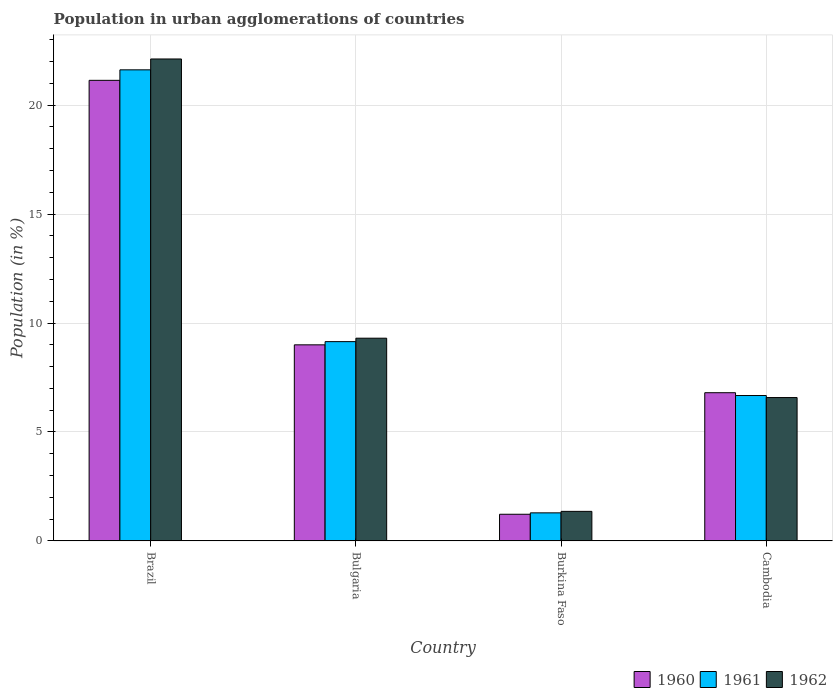How many groups of bars are there?
Make the answer very short. 4. Are the number of bars per tick equal to the number of legend labels?
Your answer should be compact. Yes. How many bars are there on the 4th tick from the right?
Make the answer very short. 3. What is the label of the 4th group of bars from the left?
Your response must be concise. Cambodia. What is the percentage of population in urban agglomerations in 1962 in Cambodia?
Offer a very short reply. 6.58. Across all countries, what is the maximum percentage of population in urban agglomerations in 1961?
Give a very brief answer. 21.62. Across all countries, what is the minimum percentage of population in urban agglomerations in 1960?
Provide a short and direct response. 1.22. In which country was the percentage of population in urban agglomerations in 1961 maximum?
Your answer should be compact. Brazil. In which country was the percentage of population in urban agglomerations in 1961 minimum?
Make the answer very short. Burkina Faso. What is the total percentage of population in urban agglomerations in 1961 in the graph?
Provide a succinct answer. 38.73. What is the difference between the percentage of population in urban agglomerations in 1960 in Brazil and that in Burkina Faso?
Your answer should be compact. 19.91. What is the difference between the percentage of population in urban agglomerations in 1960 in Brazil and the percentage of population in urban agglomerations in 1961 in Bulgaria?
Offer a very short reply. 11.99. What is the average percentage of population in urban agglomerations in 1961 per country?
Ensure brevity in your answer.  9.68. What is the difference between the percentage of population in urban agglomerations of/in 1962 and percentage of population in urban agglomerations of/in 1961 in Cambodia?
Your answer should be compact. -0.09. In how many countries, is the percentage of population in urban agglomerations in 1960 greater than 18 %?
Provide a short and direct response. 1. What is the ratio of the percentage of population in urban agglomerations in 1961 in Brazil to that in Burkina Faso?
Your answer should be compact. 16.77. Is the percentage of population in urban agglomerations in 1961 in Bulgaria less than that in Burkina Faso?
Your answer should be very brief. No. Is the difference between the percentage of population in urban agglomerations in 1962 in Burkina Faso and Cambodia greater than the difference between the percentage of population in urban agglomerations in 1961 in Burkina Faso and Cambodia?
Make the answer very short. Yes. What is the difference between the highest and the second highest percentage of population in urban agglomerations in 1960?
Provide a succinct answer. -12.14. What is the difference between the highest and the lowest percentage of population in urban agglomerations in 1961?
Ensure brevity in your answer.  20.33. In how many countries, is the percentage of population in urban agglomerations in 1961 greater than the average percentage of population in urban agglomerations in 1961 taken over all countries?
Your answer should be compact. 1. Is it the case that in every country, the sum of the percentage of population in urban agglomerations in 1961 and percentage of population in urban agglomerations in 1960 is greater than the percentage of population in urban agglomerations in 1962?
Give a very brief answer. Yes. How many bars are there?
Your answer should be compact. 12. Are all the bars in the graph horizontal?
Your response must be concise. No. What is the difference between two consecutive major ticks on the Y-axis?
Ensure brevity in your answer.  5. Where does the legend appear in the graph?
Keep it short and to the point. Bottom right. How many legend labels are there?
Keep it short and to the point. 3. What is the title of the graph?
Your answer should be compact. Population in urban agglomerations of countries. Does "1986" appear as one of the legend labels in the graph?
Make the answer very short. No. What is the label or title of the Y-axis?
Offer a very short reply. Population (in %). What is the Population (in %) of 1960 in Brazil?
Give a very brief answer. 21.14. What is the Population (in %) in 1961 in Brazil?
Make the answer very short. 21.62. What is the Population (in %) in 1962 in Brazil?
Make the answer very short. 22.12. What is the Population (in %) in 1960 in Bulgaria?
Offer a terse response. 9. What is the Population (in %) in 1961 in Bulgaria?
Your answer should be compact. 9.15. What is the Population (in %) of 1962 in Bulgaria?
Your answer should be compact. 9.3. What is the Population (in %) in 1960 in Burkina Faso?
Your answer should be very brief. 1.22. What is the Population (in %) in 1961 in Burkina Faso?
Provide a short and direct response. 1.29. What is the Population (in %) in 1962 in Burkina Faso?
Offer a terse response. 1.36. What is the Population (in %) of 1960 in Cambodia?
Your answer should be compact. 6.8. What is the Population (in %) of 1961 in Cambodia?
Offer a very short reply. 6.67. What is the Population (in %) of 1962 in Cambodia?
Offer a terse response. 6.58. Across all countries, what is the maximum Population (in %) in 1960?
Offer a terse response. 21.14. Across all countries, what is the maximum Population (in %) of 1961?
Provide a succinct answer. 21.62. Across all countries, what is the maximum Population (in %) in 1962?
Keep it short and to the point. 22.12. Across all countries, what is the minimum Population (in %) in 1960?
Provide a short and direct response. 1.22. Across all countries, what is the minimum Population (in %) in 1961?
Provide a short and direct response. 1.29. Across all countries, what is the minimum Population (in %) in 1962?
Your answer should be compact. 1.36. What is the total Population (in %) of 1960 in the graph?
Offer a terse response. 38.17. What is the total Population (in %) in 1961 in the graph?
Your answer should be compact. 38.73. What is the total Population (in %) in 1962 in the graph?
Ensure brevity in your answer.  39.36. What is the difference between the Population (in %) in 1960 in Brazil and that in Bulgaria?
Offer a very short reply. 12.14. What is the difference between the Population (in %) of 1961 in Brazil and that in Bulgaria?
Give a very brief answer. 12.47. What is the difference between the Population (in %) in 1962 in Brazil and that in Bulgaria?
Offer a very short reply. 12.81. What is the difference between the Population (in %) of 1960 in Brazil and that in Burkina Faso?
Give a very brief answer. 19.91. What is the difference between the Population (in %) in 1961 in Brazil and that in Burkina Faso?
Keep it short and to the point. 20.33. What is the difference between the Population (in %) of 1962 in Brazil and that in Burkina Faso?
Give a very brief answer. 20.76. What is the difference between the Population (in %) in 1960 in Brazil and that in Cambodia?
Offer a very short reply. 14.34. What is the difference between the Population (in %) in 1961 in Brazil and that in Cambodia?
Make the answer very short. 14.95. What is the difference between the Population (in %) of 1962 in Brazil and that in Cambodia?
Provide a succinct answer. 15.54. What is the difference between the Population (in %) in 1960 in Bulgaria and that in Burkina Faso?
Your response must be concise. 7.78. What is the difference between the Population (in %) in 1961 in Bulgaria and that in Burkina Faso?
Keep it short and to the point. 7.86. What is the difference between the Population (in %) of 1962 in Bulgaria and that in Burkina Faso?
Your answer should be very brief. 7.95. What is the difference between the Population (in %) in 1960 in Bulgaria and that in Cambodia?
Ensure brevity in your answer.  2.2. What is the difference between the Population (in %) of 1961 in Bulgaria and that in Cambodia?
Make the answer very short. 2.47. What is the difference between the Population (in %) of 1962 in Bulgaria and that in Cambodia?
Offer a terse response. 2.72. What is the difference between the Population (in %) of 1960 in Burkina Faso and that in Cambodia?
Your response must be concise. -5.58. What is the difference between the Population (in %) in 1961 in Burkina Faso and that in Cambodia?
Provide a succinct answer. -5.38. What is the difference between the Population (in %) of 1962 in Burkina Faso and that in Cambodia?
Your answer should be compact. -5.22. What is the difference between the Population (in %) of 1960 in Brazil and the Population (in %) of 1961 in Bulgaria?
Provide a succinct answer. 11.99. What is the difference between the Population (in %) in 1960 in Brazil and the Population (in %) in 1962 in Bulgaria?
Provide a short and direct response. 11.83. What is the difference between the Population (in %) of 1961 in Brazil and the Population (in %) of 1962 in Bulgaria?
Give a very brief answer. 12.32. What is the difference between the Population (in %) of 1960 in Brazil and the Population (in %) of 1961 in Burkina Faso?
Your answer should be compact. 19.85. What is the difference between the Population (in %) in 1960 in Brazil and the Population (in %) in 1962 in Burkina Faso?
Your answer should be very brief. 19.78. What is the difference between the Population (in %) in 1961 in Brazil and the Population (in %) in 1962 in Burkina Faso?
Provide a short and direct response. 20.26. What is the difference between the Population (in %) in 1960 in Brazil and the Population (in %) in 1961 in Cambodia?
Make the answer very short. 14.46. What is the difference between the Population (in %) of 1960 in Brazil and the Population (in %) of 1962 in Cambodia?
Ensure brevity in your answer.  14.56. What is the difference between the Population (in %) of 1961 in Brazil and the Population (in %) of 1962 in Cambodia?
Your response must be concise. 15.04. What is the difference between the Population (in %) of 1960 in Bulgaria and the Population (in %) of 1961 in Burkina Faso?
Make the answer very short. 7.71. What is the difference between the Population (in %) of 1960 in Bulgaria and the Population (in %) of 1962 in Burkina Faso?
Ensure brevity in your answer.  7.64. What is the difference between the Population (in %) of 1961 in Bulgaria and the Population (in %) of 1962 in Burkina Faso?
Provide a succinct answer. 7.79. What is the difference between the Population (in %) of 1960 in Bulgaria and the Population (in %) of 1961 in Cambodia?
Your response must be concise. 2.33. What is the difference between the Population (in %) in 1960 in Bulgaria and the Population (in %) in 1962 in Cambodia?
Give a very brief answer. 2.42. What is the difference between the Population (in %) in 1961 in Bulgaria and the Population (in %) in 1962 in Cambodia?
Your answer should be compact. 2.57. What is the difference between the Population (in %) in 1960 in Burkina Faso and the Population (in %) in 1961 in Cambodia?
Your response must be concise. -5.45. What is the difference between the Population (in %) of 1960 in Burkina Faso and the Population (in %) of 1962 in Cambodia?
Offer a very short reply. -5.36. What is the difference between the Population (in %) in 1961 in Burkina Faso and the Population (in %) in 1962 in Cambodia?
Your answer should be very brief. -5.29. What is the average Population (in %) of 1960 per country?
Provide a short and direct response. 9.54. What is the average Population (in %) of 1961 per country?
Your answer should be compact. 9.68. What is the average Population (in %) of 1962 per country?
Keep it short and to the point. 9.84. What is the difference between the Population (in %) of 1960 and Population (in %) of 1961 in Brazil?
Give a very brief answer. -0.48. What is the difference between the Population (in %) in 1960 and Population (in %) in 1962 in Brazil?
Give a very brief answer. -0.98. What is the difference between the Population (in %) of 1961 and Population (in %) of 1962 in Brazil?
Your response must be concise. -0.5. What is the difference between the Population (in %) in 1960 and Population (in %) in 1961 in Bulgaria?
Make the answer very short. -0.15. What is the difference between the Population (in %) of 1960 and Population (in %) of 1962 in Bulgaria?
Your answer should be compact. -0.3. What is the difference between the Population (in %) in 1961 and Population (in %) in 1962 in Bulgaria?
Ensure brevity in your answer.  -0.16. What is the difference between the Population (in %) of 1960 and Population (in %) of 1961 in Burkina Faso?
Provide a short and direct response. -0.06. What is the difference between the Population (in %) in 1960 and Population (in %) in 1962 in Burkina Faso?
Provide a succinct answer. -0.13. What is the difference between the Population (in %) of 1961 and Population (in %) of 1962 in Burkina Faso?
Provide a succinct answer. -0.07. What is the difference between the Population (in %) of 1960 and Population (in %) of 1961 in Cambodia?
Make the answer very short. 0.13. What is the difference between the Population (in %) in 1960 and Population (in %) in 1962 in Cambodia?
Provide a succinct answer. 0.22. What is the difference between the Population (in %) of 1961 and Population (in %) of 1962 in Cambodia?
Give a very brief answer. 0.09. What is the ratio of the Population (in %) of 1960 in Brazil to that in Bulgaria?
Your answer should be compact. 2.35. What is the ratio of the Population (in %) in 1961 in Brazil to that in Bulgaria?
Offer a terse response. 2.36. What is the ratio of the Population (in %) in 1962 in Brazil to that in Bulgaria?
Provide a succinct answer. 2.38. What is the ratio of the Population (in %) in 1960 in Brazil to that in Burkina Faso?
Ensure brevity in your answer.  17.27. What is the ratio of the Population (in %) in 1961 in Brazil to that in Burkina Faso?
Make the answer very short. 16.77. What is the ratio of the Population (in %) in 1962 in Brazil to that in Burkina Faso?
Offer a very short reply. 16.3. What is the ratio of the Population (in %) in 1960 in Brazil to that in Cambodia?
Make the answer very short. 3.11. What is the ratio of the Population (in %) in 1961 in Brazil to that in Cambodia?
Your answer should be compact. 3.24. What is the ratio of the Population (in %) in 1962 in Brazil to that in Cambodia?
Your response must be concise. 3.36. What is the ratio of the Population (in %) in 1960 in Bulgaria to that in Burkina Faso?
Provide a short and direct response. 7.35. What is the ratio of the Population (in %) of 1961 in Bulgaria to that in Burkina Faso?
Keep it short and to the point. 7.1. What is the ratio of the Population (in %) in 1962 in Bulgaria to that in Burkina Faso?
Give a very brief answer. 6.86. What is the ratio of the Population (in %) of 1960 in Bulgaria to that in Cambodia?
Your answer should be compact. 1.32. What is the ratio of the Population (in %) in 1961 in Bulgaria to that in Cambodia?
Provide a succinct answer. 1.37. What is the ratio of the Population (in %) in 1962 in Bulgaria to that in Cambodia?
Your answer should be very brief. 1.41. What is the ratio of the Population (in %) in 1960 in Burkina Faso to that in Cambodia?
Keep it short and to the point. 0.18. What is the ratio of the Population (in %) of 1961 in Burkina Faso to that in Cambodia?
Your answer should be very brief. 0.19. What is the ratio of the Population (in %) in 1962 in Burkina Faso to that in Cambodia?
Offer a very short reply. 0.21. What is the difference between the highest and the second highest Population (in %) in 1960?
Offer a terse response. 12.14. What is the difference between the highest and the second highest Population (in %) of 1961?
Keep it short and to the point. 12.47. What is the difference between the highest and the second highest Population (in %) of 1962?
Give a very brief answer. 12.81. What is the difference between the highest and the lowest Population (in %) of 1960?
Provide a succinct answer. 19.91. What is the difference between the highest and the lowest Population (in %) of 1961?
Provide a succinct answer. 20.33. What is the difference between the highest and the lowest Population (in %) in 1962?
Your response must be concise. 20.76. 